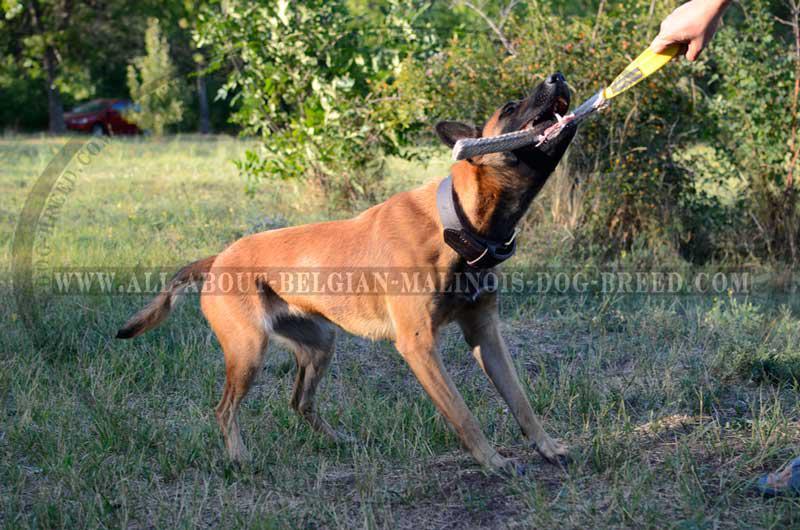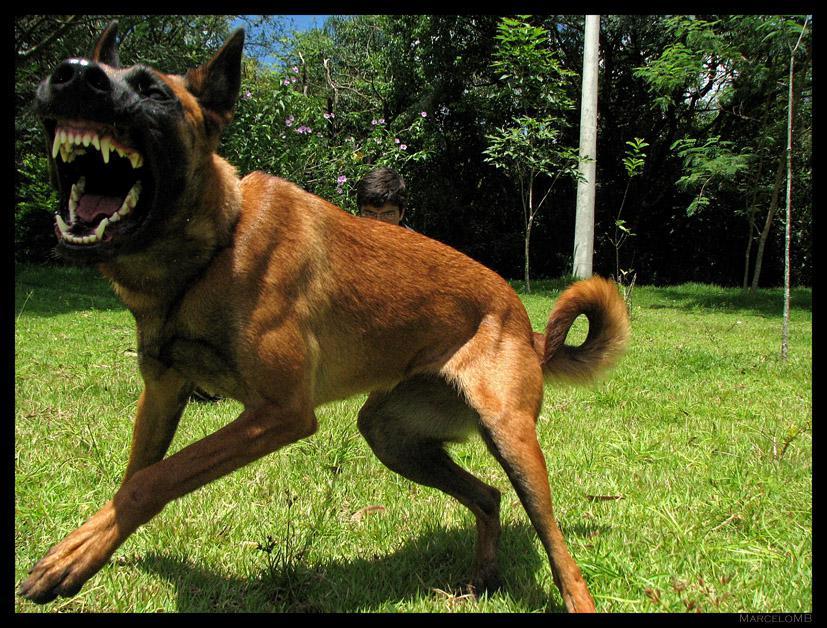The first image is the image on the left, the second image is the image on the right. Assess this claim about the two images: "The dog on the right has an open non-snarling mouth with tongue out, and the dog on the right has something with multiple straps in front of its face that is not a dog collar.". Correct or not? Answer yes or no. No. The first image is the image on the left, the second image is the image on the right. Assess this claim about the two images: "One of the dogs is on a leash.". Correct or not? Answer yes or no. No. 